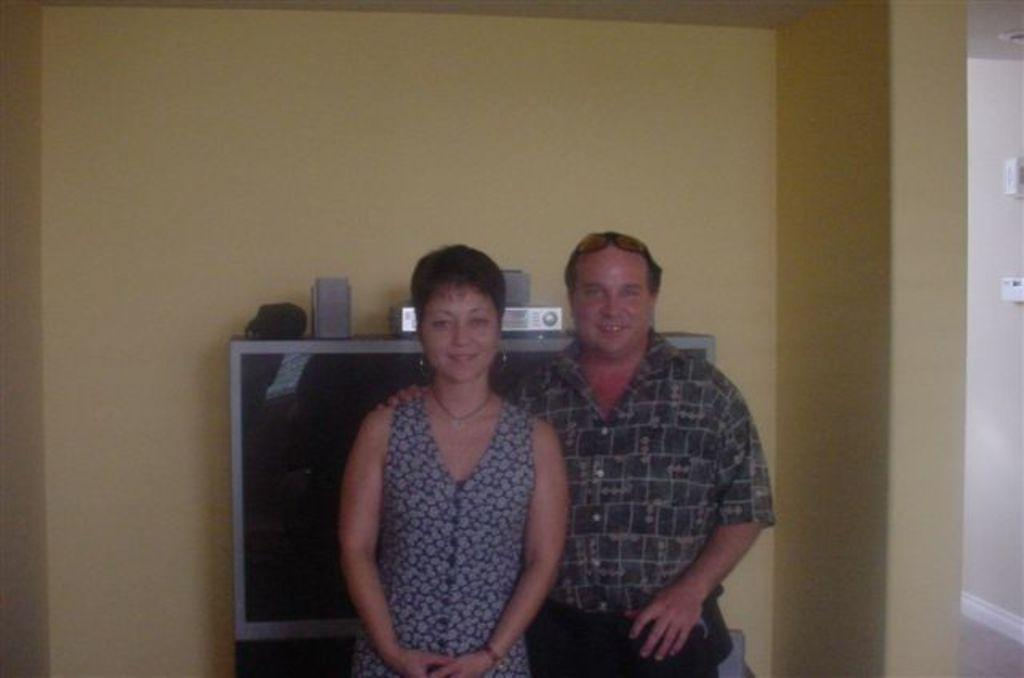Who or what can be seen in the image? There are people in the image. What is the background of the image? There is a wall in the image. What is on the wall? There are objects on the wall. What type of fog can be seen in the image? There is no fog present in the image. What role does the minister play in the image? There is no minister present in the image. 